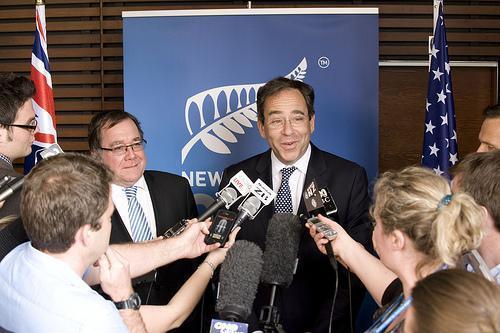How many flags are in the photo?
Give a very brief answer. 2. 